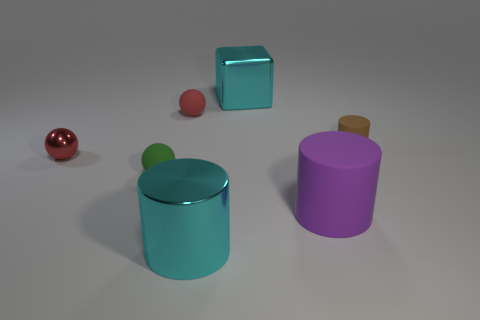The red matte ball is what size?
Ensure brevity in your answer.  Small. How many other red spheres have the same size as the shiny sphere?
Offer a terse response. 1. Is the number of big purple rubber objects in front of the small red matte object less than the number of large cyan objects behind the cyan cylinder?
Give a very brief answer. No. There is a red thing in front of the rubber cylinder behind the rubber ball left of the red matte ball; what size is it?
Provide a succinct answer. Small. There is a rubber thing that is both to the left of the big cyan metal cylinder and in front of the metallic sphere; what is its size?
Provide a succinct answer. Small. The big metal object that is behind the purple rubber cylinder on the right side of the red matte object is what shape?
Offer a very short reply. Cube. Is there anything else that is the same color as the tiny shiny thing?
Keep it short and to the point. Yes. There is a cyan metallic thing that is behind the metallic cylinder; what is its shape?
Keep it short and to the point. Cube. What shape is the thing that is behind the green matte ball and left of the small red rubber object?
Give a very brief answer. Sphere. What number of cyan objects are either small matte balls or big metal things?
Your answer should be compact. 2. 